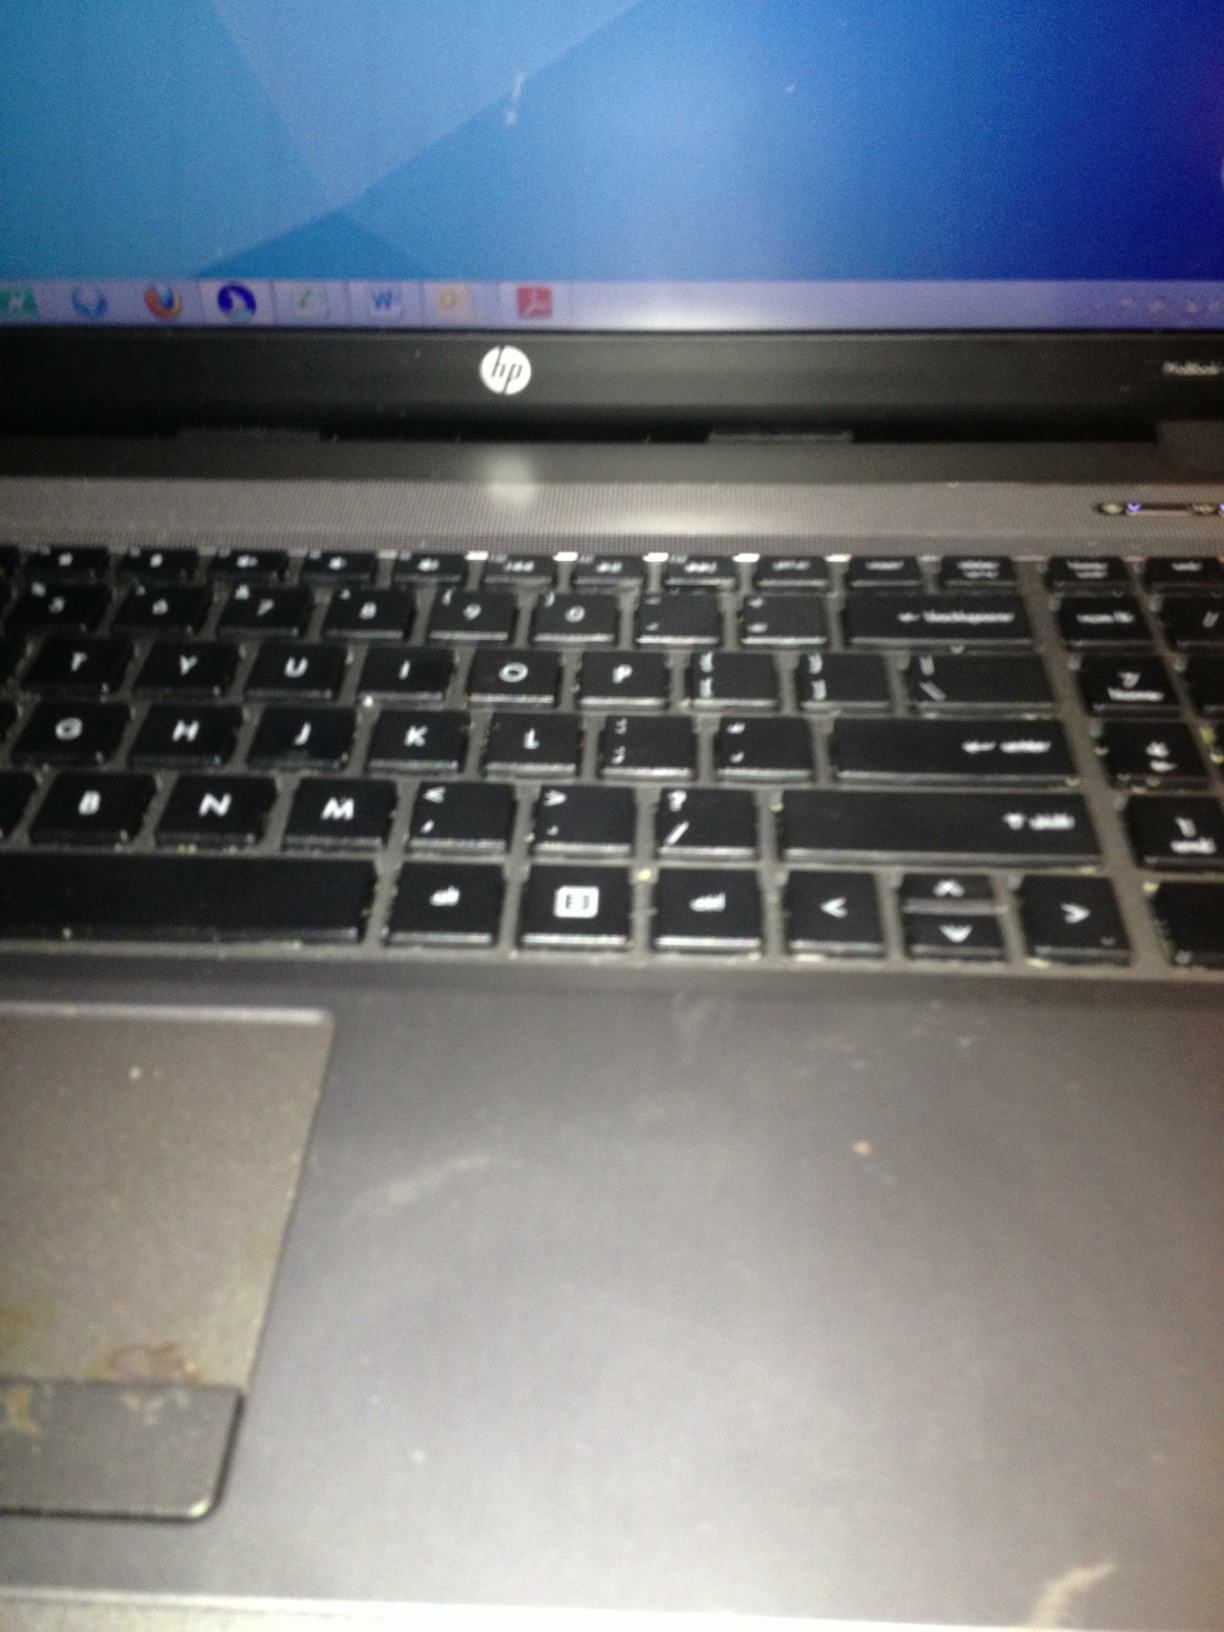Imagine this laptop was a character in a story. What kind of character would it be? This HP laptop, marked by visible wear and a slightly faded keyboard, would be an experienced and wise character - perhaps a seasoned mentor or sage. It carries the scars of countless tasks, equipped with vast knowledge and stories from numerous digital battles. Despite its age, it remains reliable and steadfast, always ready to impart wisdom and tackle new challenges. 